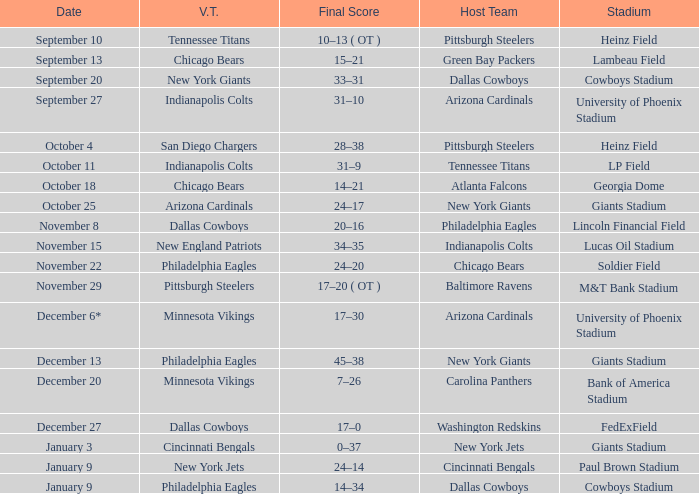Tell me the final score for january 9 for cincinnati bengals 24–14. 